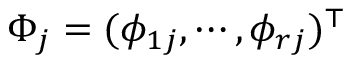<formula> <loc_0><loc_0><loc_500><loc_500>\Phi _ { j } = ( \phi _ { 1 j } , \cdots , \phi _ { r j } ) ^ { \top }</formula> 